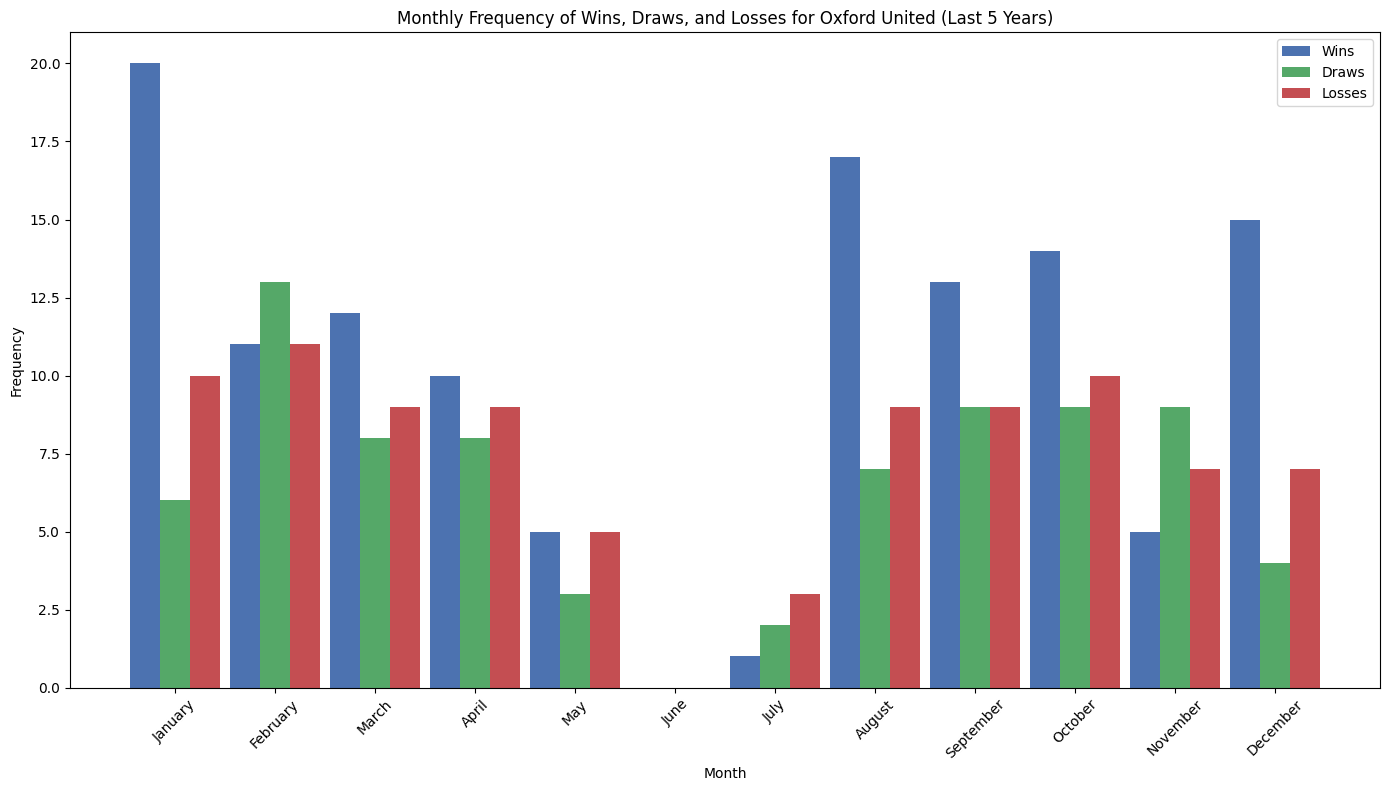Which month has the highest number of wins overall? By looking at the heights of the blue bars representing wins, the tallest blue bar indicates the month with the highest number of wins.
Answer: January Which month has more losses, September or October? Comparing the heights of the red bars for September and October, the taller red bar represents the month with more losses.
Answer: October What is the average number of draws in a year? Sum all green bars (draws) and divide by 12 (the number of months). The sum of the draws bars is 38; hence, the average is 38/12, which is approximately 3.17.
Answer: 3.17 In which month are the draws equal to the number of losses? By examining the green and red bars' heights, identify the month where the two bars have equal height.
Answer: November For which month is the total number of wins, draws, and losses the highest? Add the heights of the blue, green, and red bars for each month. The month with the tallest combined height has the highest total.
Answer: January Does any month have an equal number of wins and draws? Compare the heights of the blue and green bars for each month to find any matching pairs.
Answer: Yes, February In which month are the losses the lowest? Identify the month with the shortest red bar, which indicates the least number of losses.
Answer: June How many more wins does August have compared to February? Find the height difference between the blue bars of August and February. August has 16 wins, and February has 11. The difference is 16 - 11.
Answer: 5 Which month shows the highest variation between wins, draws, and losses? Compare the months where the heights of the blue, green, and red bars differ the most from each other.
Answer: February Is there any month where the combined total of wins and draws equals the number of losses? Check for the month where the sum of the blue and green bars equals the height of the red bar.
Answer: No 